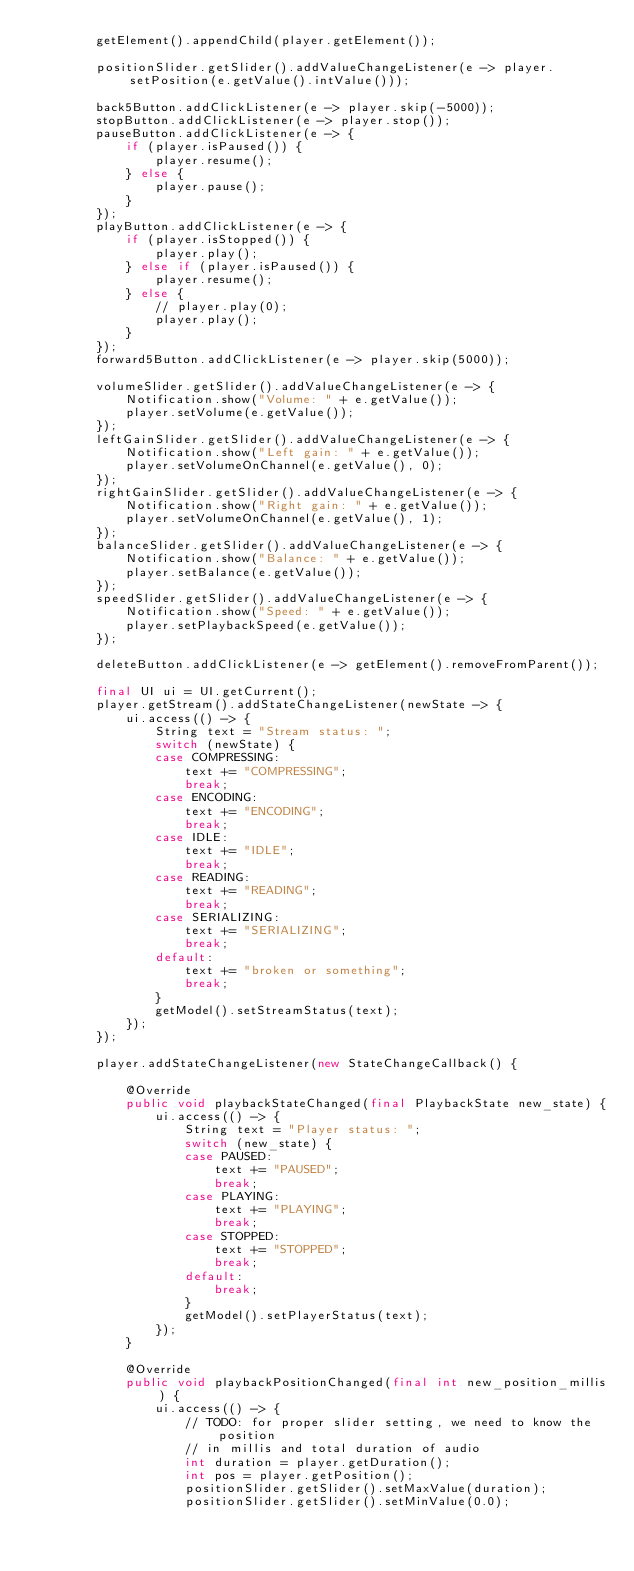<code> <loc_0><loc_0><loc_500><loc_500><_Java_>        getElement().appendChild(player.getElement());

        positionSlider.getSlider().addValueChangeListener(e -> player.setPosition(e.getValue().intValue()));

        back5Button.addClickListener(e -> player.skip(-5000));
        stopButton.addClickListener(e -> player.stop());
        pauseButton.addClickListener(e -> {
            if (player.isPaused()) {
                player.resume();
            } else {
                player.pause();
            }
        });
        playButton.addClickListener(e -> {
            if (player.isStopped()) {
                player.play();
            } else if (player.isPaused()) {
                player.resume();
            } else {
                // player.play(0);
                player.play();
            }
        });
        forward5Button.addClickListener(e -> player.skip(5000));

        volumeSlider.getSlider().addValueChangeListener(e -> {
            Notification.show("Volume: " + e.getValue());
            player.setVolume(e.getValue());
        });
        leftGainSlider.getSlider().addValueChangeListener(e -> {
            Notification.show("Left gain: " + e.getValue());
            player.setVolumeOnChannel(e.getValue(), 0);
        });
        rightGainSlider.getSlider().addValueChangeListener(e -> {
            Notification.show("Right gain: " + e.getValue());
            player.setVolumeOnChannel(e.getValue(), 1);
        });
        balanceSlider.getSlider().addValueChangeListener(e -> {
            Notification.show("Balance: " + e.getValue());
            player.setBalance(e.getValue());
        });
        speedSlider.getSlider().addValueChangeListener(e -> {
            Notification.show("Speed: " + e.getValue());
            player.setPlaybackSpeed(e.getValue());
        });

        deleteButton.addClickListener(e -> getElement().removeFromParent());

        final UI ui = UI.getCurrent();
        player.getStream().addStateChangeListener(newState -> {
            ui.access(() -> {
                String text = "Stream status: ";
                switch (newState) {
                case COMPRESSING:
                    text += "COMPRESSING";
                    break;
                case ENCODING:
                    text += "ENCODING";
                    break;
                case IDLE:
                    text += "IDLE";
                    break;
                case READING:
                    text += "READING";
                    break;
                case SERIALIZING:
                    text += "SERIALIZING";
                    break;
                default:
                    text += "broken or something";
                    break;
                }
                getModel().setStreamStatus(text);
            });
        });

        player.addStateChangeListener(new StateChangeCallback() {

            @Override
            public void playbackStateChanged(final PlaybackState new_state) {
                ui.access(() -> {
                    String text = "Player status: ";
                    switch (new_state) {
                    case PAUSED:
                        text += "PAUSED";
                        break;
                    case PLAYING:
                        text += "PLAYING";
                        break;
                    case STOPPED:
                        text += "STOPPED";
                        break;
                    default:
                        break;
                    }
                    getModel().setPlayerStatus(text);
                });
            }

            @Override
            public void playbackPositionChanged(final int new_position_millis) {
                ui.access(() -> {
                    // TODO: for proper slider setting, we need to know the position
                    // in millis and total duration of audio
                    int duration = player.getDuration();
                    int pos = player.getPosition();
                    positionSlider.getSlider().setMaxValue(duration);
                    positionSlider.getSlider().setMinValue(0.0);</code> 